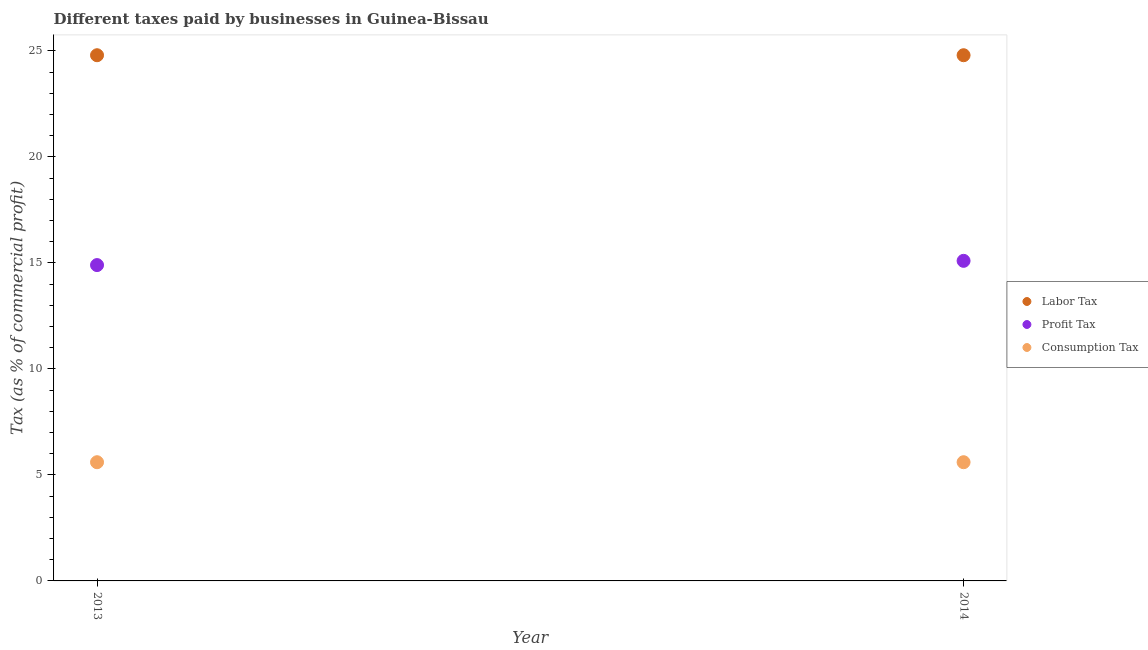How many different coloured dotlines are there?
Your answer should be very brief. 3. Is the number of dotlines equal to the number of legend labels?
Provide a succinct answer. Yes. What is the percentage of consumption tax in 2014?
Provide a short and direct response. 5.6. In which year was the percentage of labor tax minimum?
Your answer should be compact. 2013. What is the total percentage of consumption tax in the graph?
Keep it short and to the point. 11.2. What is the difference between the percentage of labor tax in 2013 and that in 2014?
Your answer should be compact. 0. What is the average percentage of labor tax per year?
Offer a terse response. 24.8. In the year 2014, what is the difference between the percentage of labor tax and percentage of consumption tax?
Provide a succinct answer. 19.2. What is the ratio of the percentage of profit tax in 2013 to that in 2014?
Offer a terse response. 0.99. Is the percentage of profit tax in 2013 less than that in 2014?
Your answer should be very brief. Yes. In how many years, is the percentage of profit tax greater than the average percentage of profit tax taken over all years?
Your response must be concise. 1. Is it the case that in every year, the sum of the percentage of labor tax and percentage of profit tax is greater than the percentage of consumption tax?
Your answer should be compact. Yes. How many dotlines are there?
Make the answer very short. 3. How many years are there in the graph?
Ensure brevity in your answer.  2. Does the graph contain grids?
Your answer should be compact. No. Where does the legend appear in the graph?
Make the answer very short. Center right. What is the title of the graph?
Keep it short and to the point. Different taxes paid by businesses in Guinea-Bissau. What is the label or title of the X-axis?
Keep it short and to the point. Year. What is the label or title of the Y-axis?
Provide a succinct answer. Tax (as % of commercial profit). What is the Tax (as % of commercial profit) of Labor Tax in 2013?
Offer a very short reply. 24.8. What is the Tax (as % of commercial profit) of Consumption Tax in 2013?
Your answer should be compact. 5.6. What is the Tax (as % of commercial profit) of Labor Tax in 2014?
Provide a succinct answer. 24.8. What is the Tax (as % of commercial profit) in Profit Tax in 2014?
Offer a very short reply. 15.1. Across all years, what is the maximum Tax (as % of commercial profit) in Labor Tax?
Offer a terse response. 24.8. Across all years, what is the maximum Tax (as % of commercial profit) of Profit Tax?
Offer a terse response. 15.1. Across all years, what is the maximum Tax (as % of commercial profit) in Consumption Tax?
Make the answer very short. 5.6. Across all years, what is the minimum Tax (as % of commercial profit) in Labor Tax?
Your answer should be compact. 24.8. What is the total Tax (as % of commercial profit) in Labor Tax in the graph?
Your response must be concise. 49.6. What is the total Tax (as % of commercial profit) of Profit Tax in the graph?
Ensure brevity in your answer.  30. What is the difference between the Tax (as % of commercial profit) of Consumption Tax in 2013 and that in 2014?
Offer a terse response. 0. What is the difference between the Tax (as % of commercial profit) of Labor Tax in 2013 and the Tax (as % of commercial profit) of Profit Tax in 2014?
Give a very brief answer. 9.7. What is the difference between the Tax (as % of commercial profit) of Labor Tax in 2013 and the Tax (as % of commercial profit) of Consumption Tax in 2014?
Provide a short and direct response. 19.2. What is the average Tax (as % of commercial profit) in Labor Tax per year?
Offer a terse response. 24.8. In the year 2013, what is the difference between the Tax (as % of commercial profit) in Profit Tax and Tax (as % of commercial profit) in Consumption Tax?
Provide a short and direct response. 9.3. In the year 2014, what is the difference between the Tax (as % of commercial profit) in Labor Tax and Tax (as % of commercial profit) in Profit Tax?
Give a very brief answer. 9.7. In the year 2014, what is the difference between the Tax (as % of commercial profit) of Labor Tax and Tax (as % of commercial profit) of Consumption Tax?
Provide a short and direct response. 19.2. In the year 2014, what is the difference between the Tax (as % of commercial profit) of Profit Tax and Tax (as % of commercial profit) of Consumption Tax?
Provide a succinct answer. 9.5. What is the ratio of the Tax (as % of commercial profit) in Labor Tax in 2013 to that in 2014?
Offer a terse response. 1. What is the ratio of the Tax (as % of commercial profit) of Consumption Tax in 2013 to that in 2014?
Provide a succinct answer. 1. What is the difference between the highest and the second highest Tax (as % of commercial profit) of Labor Tax?
Make the answer very short. 0. What is the difference between the highest and the second highest Tax (as % of commercial profit) in Consumption Tax?
Provide a succinct answer. 0. What is the difference between the highest and the lowest Tax (as % of commercial profit) of Labor Tax?
Provide a succinct answer. 0. What is the difference between the highest and the lowest Tax (as % of commercial profit) of Profit Tax?
Provide a short and direct response. 0.2. 